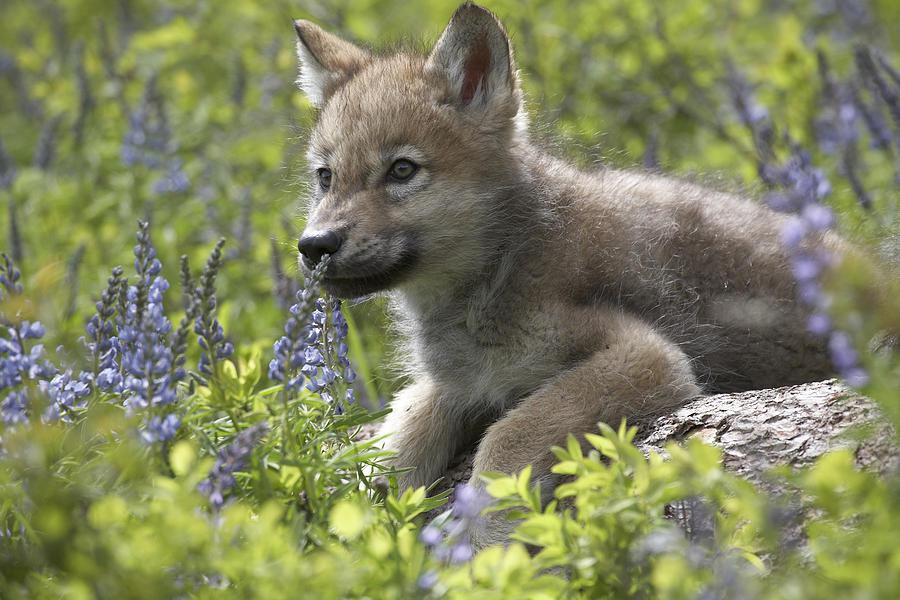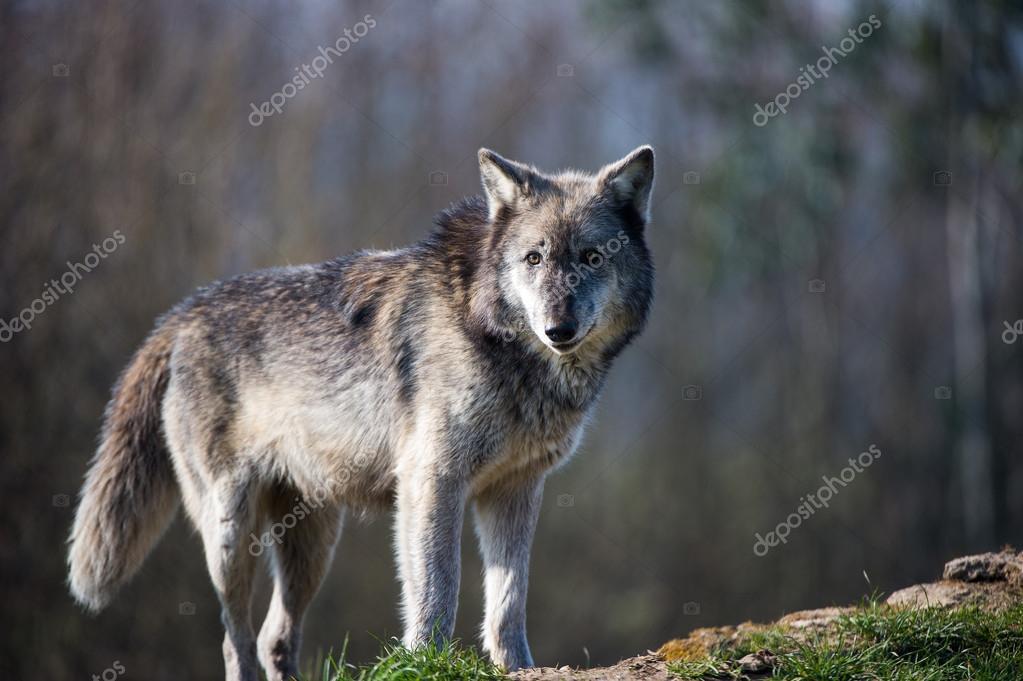The first image is the image on the left, the second image is the image on the right. Given the left and right images, does the statement "An image shows only one wolf, standing with its head and body angled rightward, and leaves visible behind it." hold true? Answer yes or no. No. 